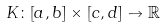<formula> <loc_0><loc_0><loc_500><loc_500>K \colon [ a , b ] \times [ c , d ] \to { \mathbb { R } }</formula> 